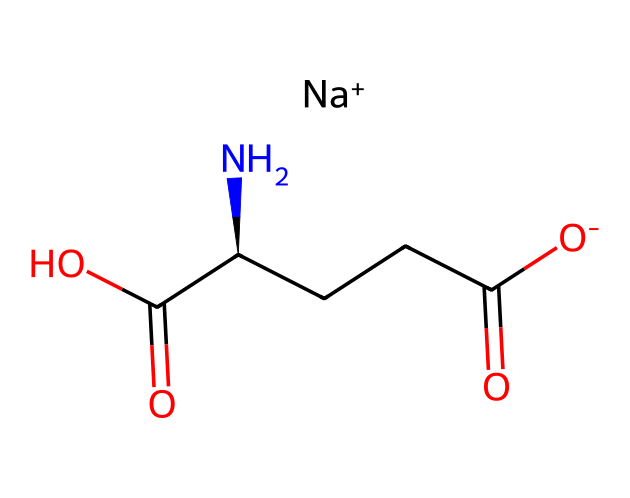What is the molecular formula of monosodium glutamate? The SMILES representation includes components such as the sodium ([Na+]), carbon (C), hydrogen (H), nitrogen (N), and oxygen (O). Counting all the atoms gives the molecular formula C5H8N1Na1O4.
Answer: C5H8N1Na1O4 How many carbon atoms are in monosodium glutamate? Analyzing the SMILES string, there are five carbon (C) atoms represented. Counting each 'C' gives the total.
Answer: 5 What functional groups does monosodium glutamate contain? In the structure, we can identify a carboxylic acid group (-COOH) represented in the formula, as well as an amine group (-NH2) which indicates the presence of these functional groups.
Answer: carboxylic acid and amine Does monosodium glutamate contain any nitrogen atoms? In the SMILES string, the presence of an 'N' indicates that there is one nitrogen atom in the molecule, specifically in the amine group.
Answer: yes What role does the sodium ion play in the structure of monosodium glutamate? The sodium ion (indicated by [Na+]) is essential for solubility and stability in food applications, allowing the flavor enhancer to perform effectively in culinary uses.
Answer: enhances solubility How does the presence of the amine group affect the flavor of monosodium glutamate? The amine group contributes to the chemical's ability to enhance umami flavor, as amino acids are known for their savory taste, enhancing overall flavor perception.
Answer: enhances umami flavor What is the primary use of monosodium glutamate in Thai cuisine? Monosodium glutamate is primarily used as a flavor enhancer to boost the savory taste of dishes, making it a common additive in various Thai recipes.
Answer: flavor enhancer 